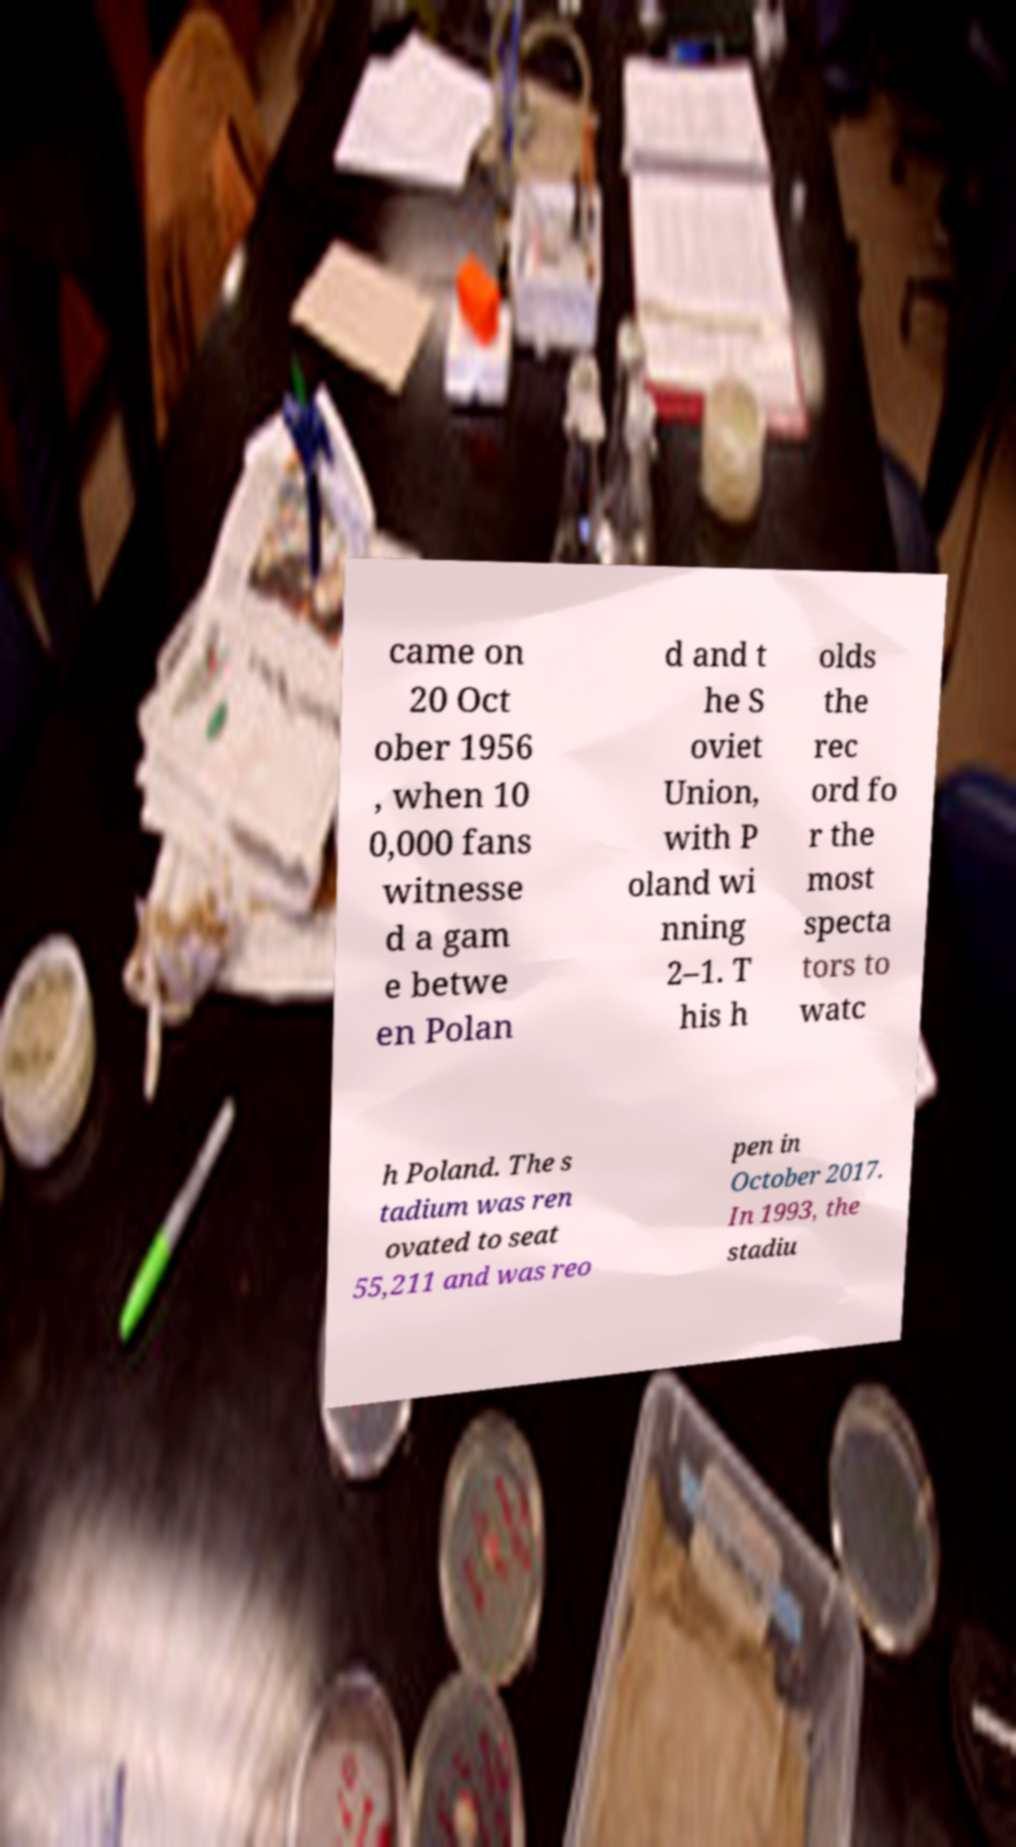I need the written content from this picture converted into text. Can you do that? came on 20 Oct ober 1956 , when 10 0,000 fans witnesse d a gam e betwe en Polan d and t he S oviet Union, with P oland wi nning 2–1. T his h olds the rec ord fo r the most specta tors to watc h Poland. The s tadium was ren ovated to seat 55,211 and was reo pen in October 2017. In 1993, the stadiu 